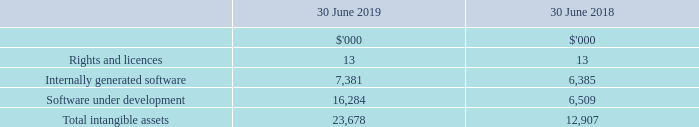11 Intangible assets
(a) Intangible assets
RIGHTS AND LICENCES
Certain licences that NEXTDC possesses have an indefinite useful life and are carried at cost less impairment losses and are subject to impairment review at least annually and whenever there is an indication that it may be impaired.
Other licences that NEXTDC acquires are carried at cost less accumulated amortisation and accumulated impairment losses. Amortisation is recognised on a straight-line basis over the estimated useful life. The estimated useful life and amortisation method are reviewed at the end of each annual reporting period.
INTERNALLY GENERATED SOFTWARE
Internally developed software is capitalised at cost less accumulated amortisation. Amortisation is calculated using the straight-line basis over the asset’s useful economic life which is generally two to three years. Their useful lives and potential impairment are reviewed at the end of each financial year.
SOFTWARE UNDER DEVELOPMENT
Costs incurred in developing products or systems and costs incurred in acquiring software and licenses that will contribute to future period financial benefits through revenue generation and/or cost reduction are capitalised to software and systems. Costs capitalised include external direct costs of materials and services and employee costs.
Assets in the course of construction include only those costs directly attributable to the development phase and are only recognised following completion of technical feasibility and where the Group has an intention and ability to use the asset.
What does costs capitalised include? External direct costs of materials and service, employee costs. What was the total intangible assets in 2019?
Answer scale should be: thousand. 23,678. What was the value of Rights and licences in 2019 and 2018 respectively?
Answer scale should be: thousand. 13, 13. What was the percentage change in internally generated software between 2018 and 2019?
Answer scale should be: percent. (7,381 - 6,385) / 6,385 
Answer: 15.6. What was the percentage change in software under development between 2018 and 2019?
Answer scale should be: percent. (16,284 - 6,509) / 6,509 
Answer: 150.18. What was the percentage change in rights and licences between 2018 and 2019?
Answer scale should be: percent. (13 - 13) / 13 
Answer: 0. 